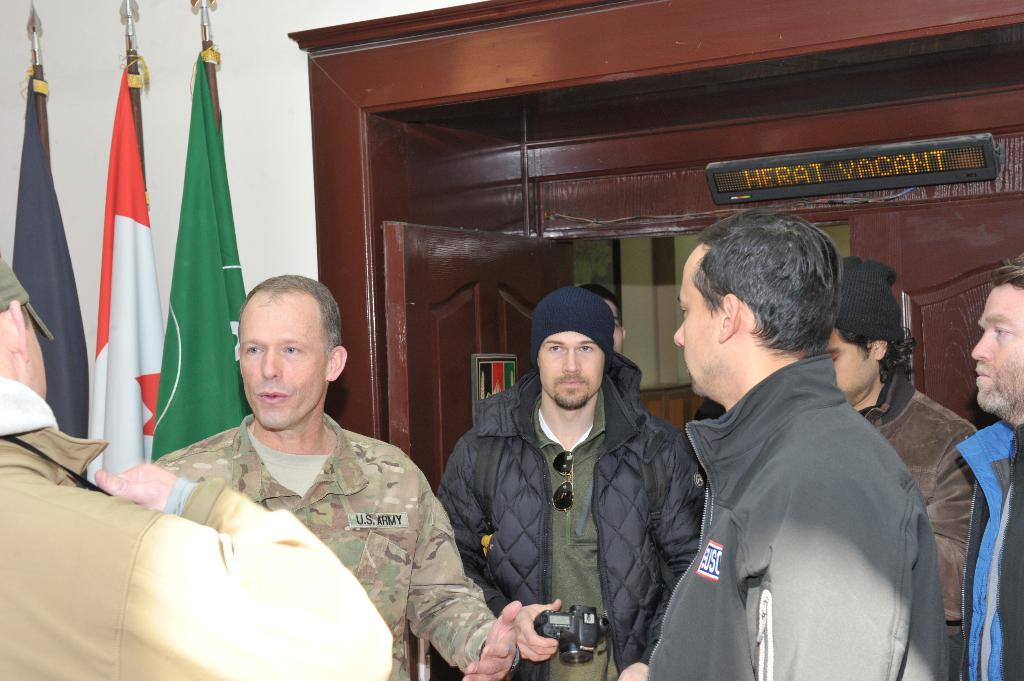How many people are in the image? There are people in the image, but the exact number is not specified. What is the man holding in the image? The man is standing and holding a camera. What can be seen in the image besides people? There are flags, boards, a door, and a wall visible in the background of the image. What type of sofa can be seen in the image? There is no sofa present in the image. How many worms are crawling on the boards in the image? There are no worms visible in the image. 